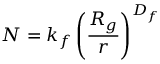<formula> <loc_0><loc_0><loc_500><loc_500>N = k _ { f } \left ( \frac { R _ { g } } { r } \right ) ^ { D _ { f } }</formula> 